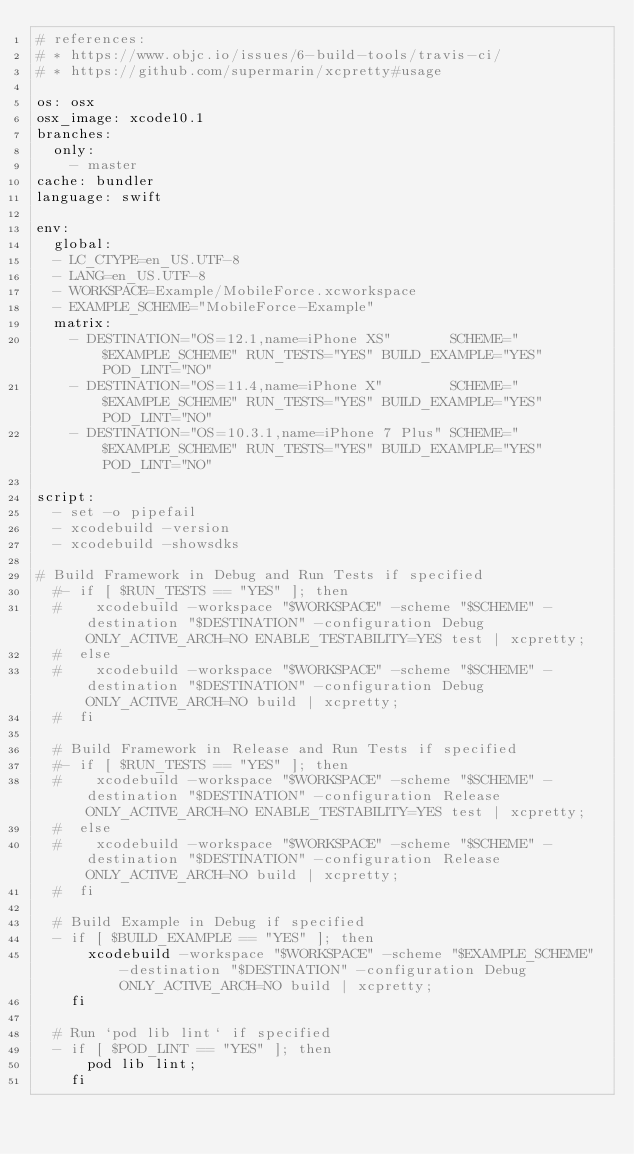<code> <loc_0><loc_0><loc_500><loc_500><_YAML_># references:
# * https://www.objc.io/issues/6-build-tools/travis-ci/
# * https://github.com/supermarin/xcpretty#usage

os: osx
osx_image: xcode10.1
branches:
  only:
    - master
cache: bundler
language: swift

env:
  global:
  - LC_CTYPE=en_US.UTF-8
  - LANG=en_US.UTF-8
  - WORKSPACE=Example/MobileForce.xcworkspace
  - EXAMPLE_SCHEME="MobileForce-Example"
  matrix:
    - DESTINATION="OS=12.1,name=iPhone XS"       SCHEME="$EXAMPLE_SCHEME" RUN_TESTS="YES" BUILD_EXAMPLE="YES" POD_LINT="NO"
    - DESTINATION="OS=11.4,name=iPhone X"        SCHEME="$EXAMPLE_SCHEME" RUN_TESTS="YES" BUILD_EXAMPLE="YES" POD_LINT="NO"
    - DESTINATION="OS=10.3.1,name=iPhone 7 Plus" SCHEME="$EXAMPLE_SCHEME" RUN_TESTS="YES" BUILD_EXAMPLE="YES" POD_LINT="NO"

script:
  - set -o pipefail
  - xcodebuild -version
  - xcodebuild -showsdks

# Build Framework in Debug and Run Tests if specified
  #- if [ $RUN_TESTS == "YES" ]; then
  #    xcodebuild -workspace "$WORKSPACE" -scheme "$SCHEME" -destination "$DESTINATION" -configuration Debug ONLY_ACTIVE_ARCH=NO ENABLE_TESTABILITY=YES test | xcpretty;
  #  else
  #    xcodebuild -workspace "$WORKSPACE" -scheme "$SCHEME" -destination "$DESTINATION" -configuration Debug ONLY_ACTIVE_ARCH=NO build | xcpretty;
  #  fi

  # Build Framework in Release and Run Tests if specified
  #- if [ $RUN_TESTS == "YES" ]; then
  #    xcodebuild -workspace "$WORKSPACE" -scheme "$SCHEME" -destination "$DESTINATION" -configuration Release ONLY_ACTIVE_ARCH=NO ENABLE_TESTABILITY=YES test | xcpretty;
  #  else
  #    xcodebuild -workspace "$WORKSPACE" -scheme "$SCHEME" -destination "$DESTINATION" -configuration Release ONLY_ACTIVE_ARCH=NO build | xcpretty;
  #  fi

  # Build Example in Debug if specified
  - if [ $BUILD_EXAMPLE == "YES" ]; then
      xcodebuild -workspace "$WORKSPACE" -scheme "$EXAMPLE_SCHEME" -destination "$DESTINATION" -configuration Debug ONLY_ACTIVE_ARCH=NO build | xcpretty;
    fi

  # Run `pod lib lint` if specified
  - if [ $POD_LINT == "YES" ]; then
      pod lib lint;
    fi
</code> 